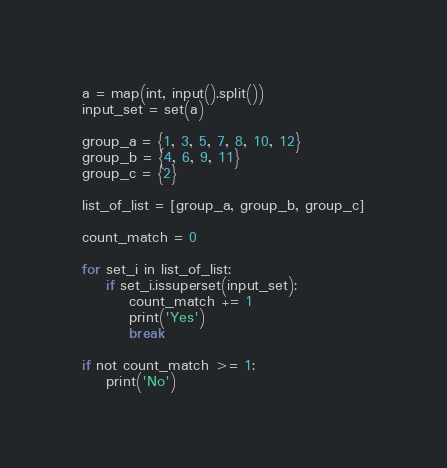<code> <loc_0><loc_0><loc_500><loc_500><_Python_>a = map(int, input().split())
input_set = set(a)

group_a = {1, 3, 5, 7, 8, 10, 12}
group_b = {4, 6, 9, 11}
group_c = {2}

list_of_list = [group_a, group_b, group_c]

count_match = 0

for set_i in list_of_list:
    if set_i.issuperset(input_set):
        count_match += 1
        print('Yes')
        break

if not count_match >= 1:
    print('No')</code> 